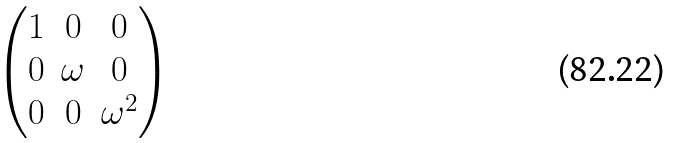<formula> <loc_0><loc_0><loc_500><loc_500>\begin{pmatrix} 1 & 0 & 0 \\ 0 & \omega & 0 \\ 0 & 0 & \omega ^ { 2 } \end{pmatrix}</formula> 